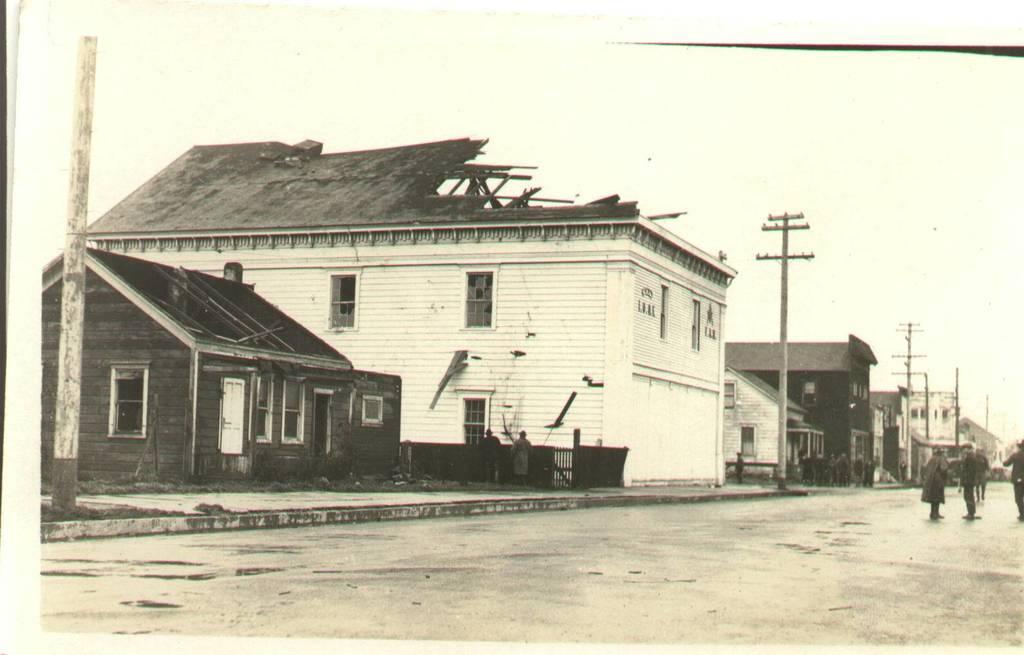Please provide a concise description of this image. In this image we can see a black and white photo. In this image we can see some buildings, poles, people and other objects. At the bottom of the image there is the road. At the top of the image there is the sky. 